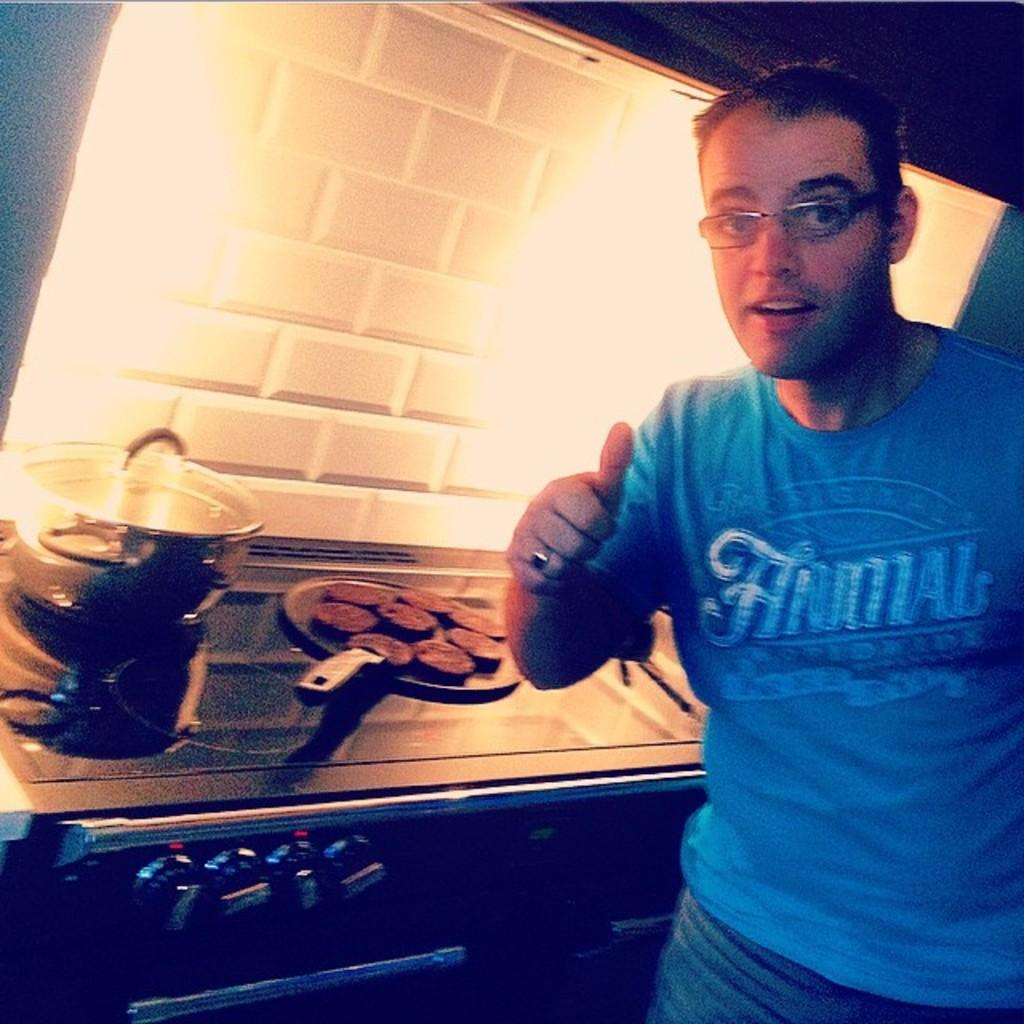Provide a one-sentence caption for the provided image. A man gives a thumbs up while wearing a blue shirt that says ANIMAL. 